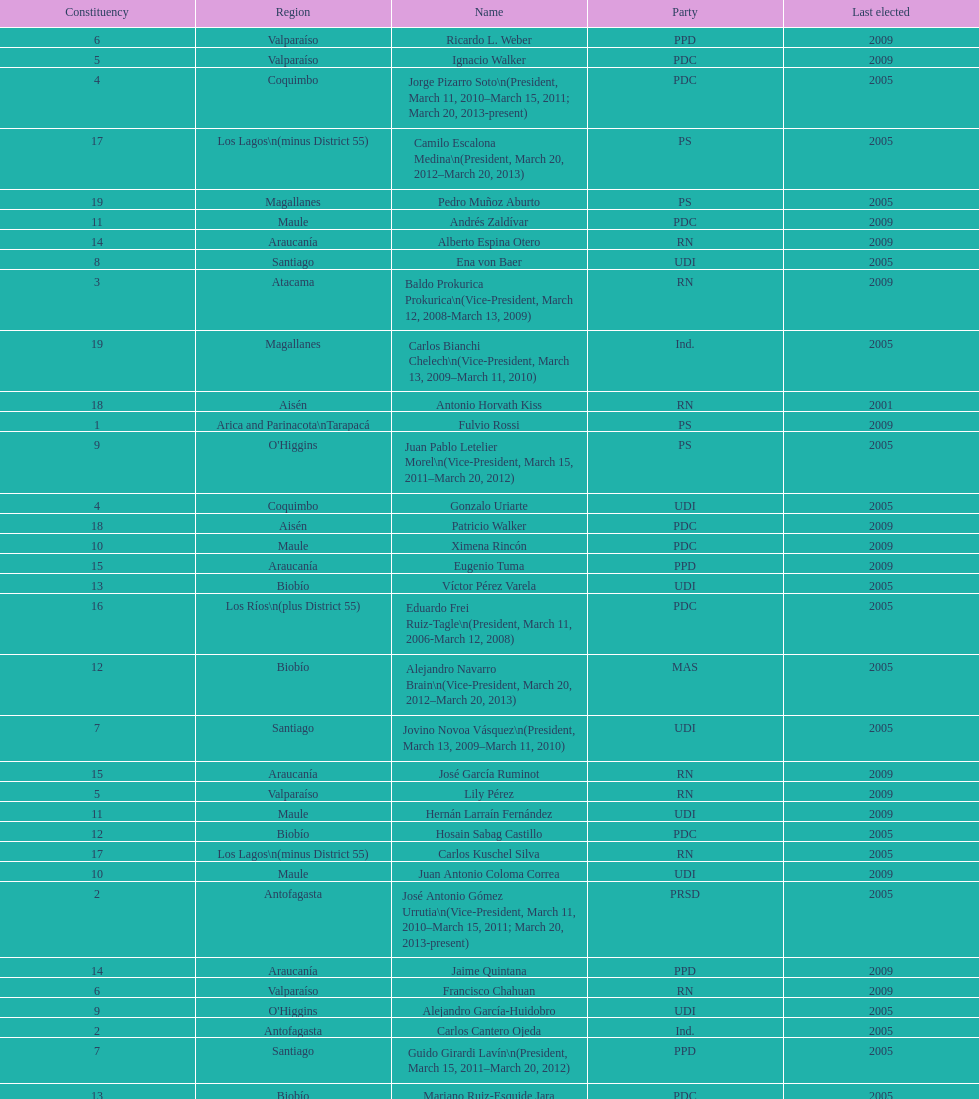How long was baldo prokurica prokurica vice-president? 1 year. 